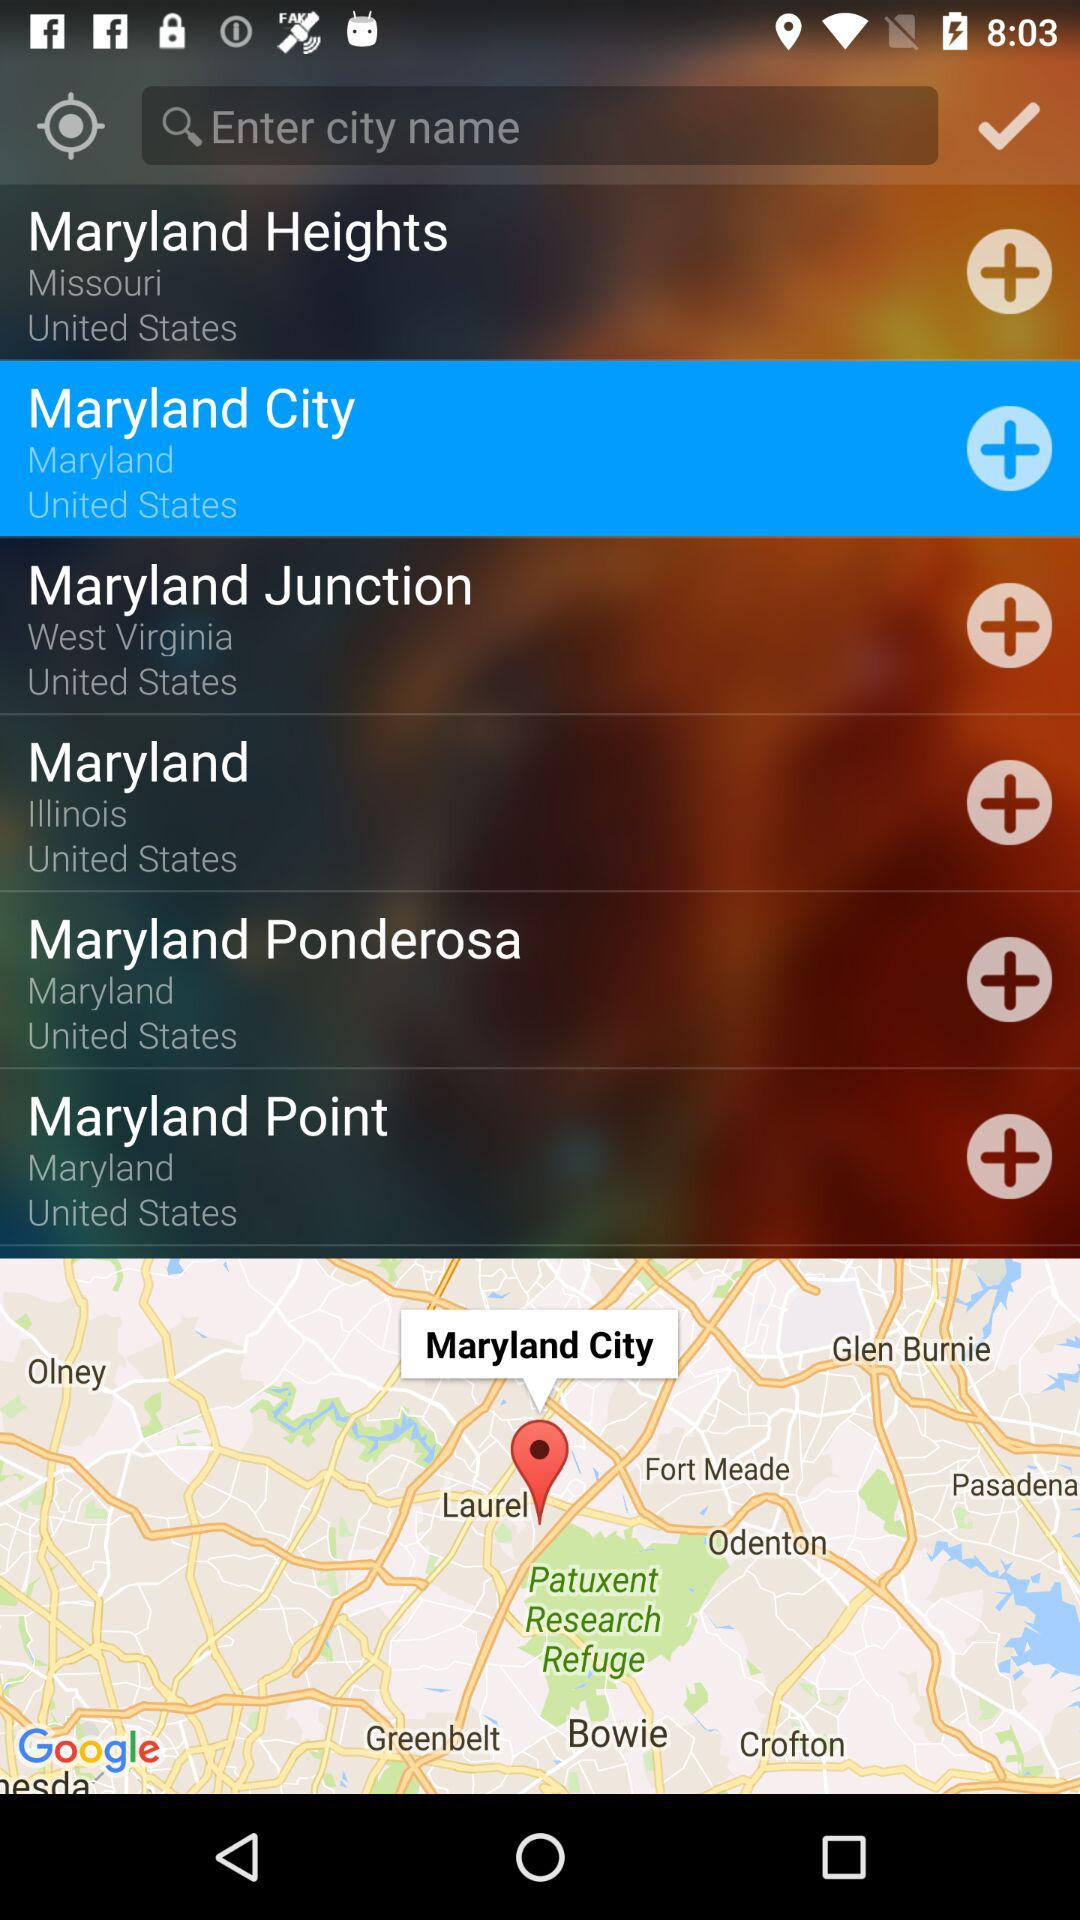What is the selected option? The selected option is "Maryland City". 